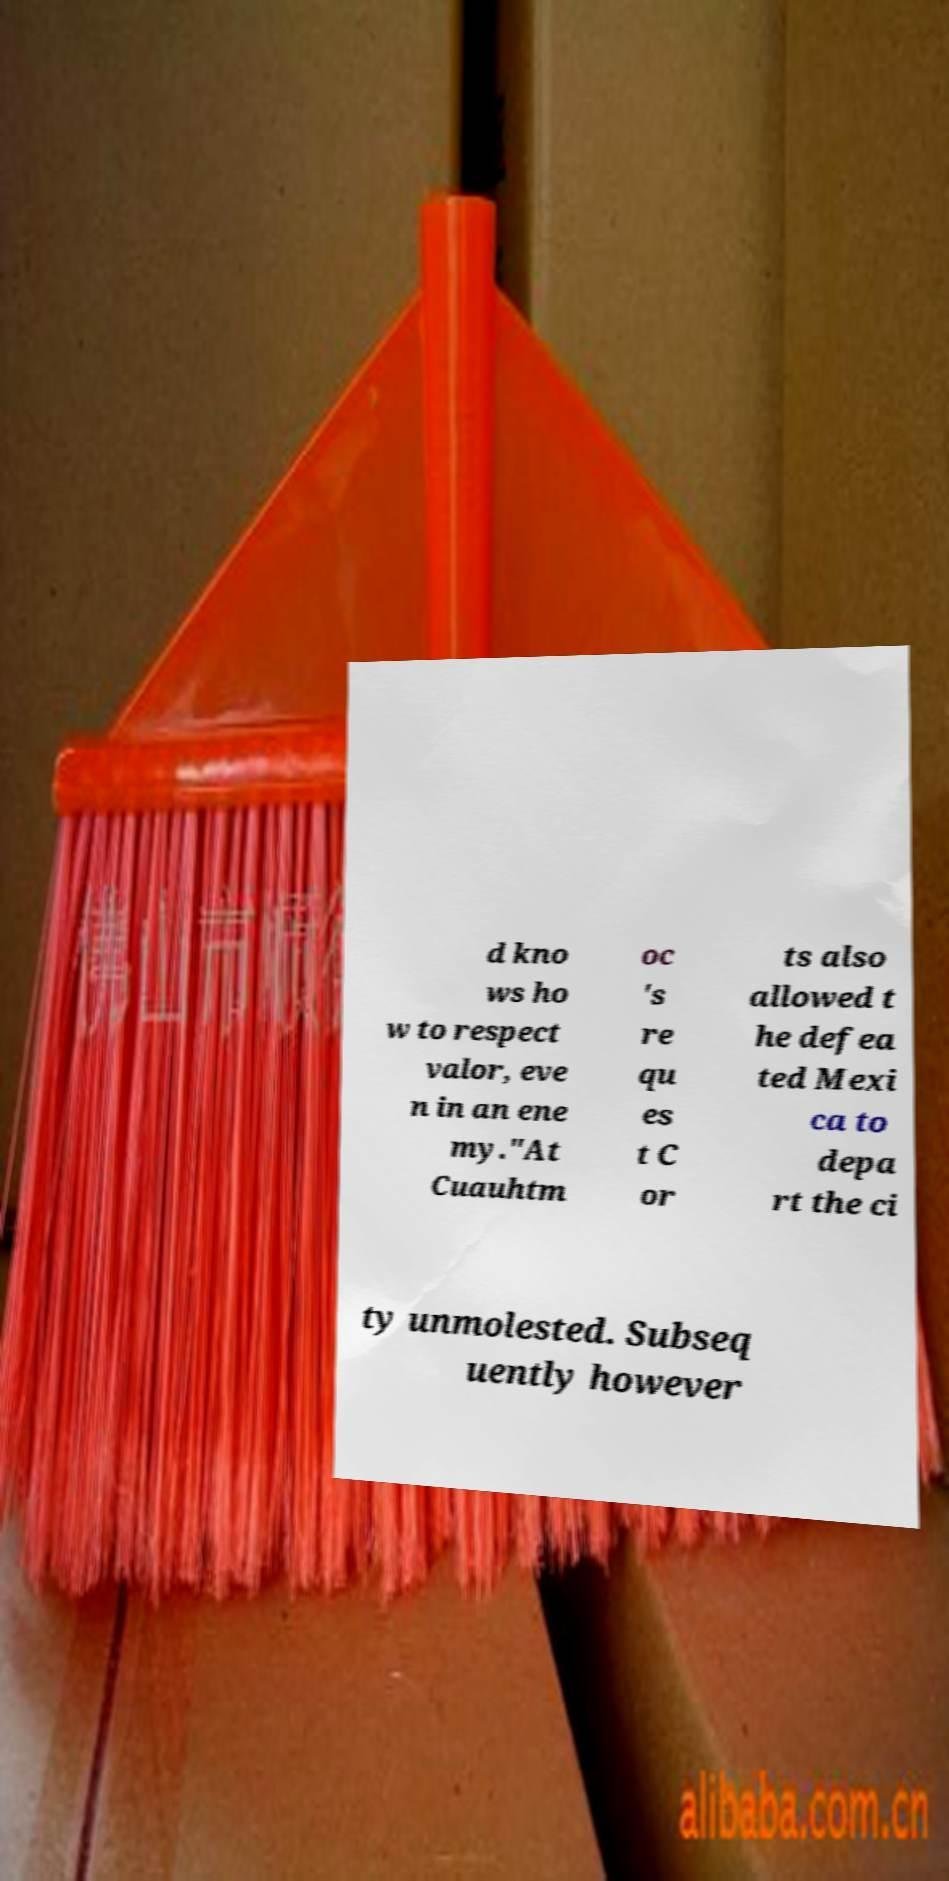Please identify and transcribe the text found in this image. d kno ws ho w to respect valor, eve n in an ene my."At Cuauhtm oc 's re qu es t C or ts also allowed t he defea ted Mexi ca to depa rt the ci ty unmolested. Subseq uently however 